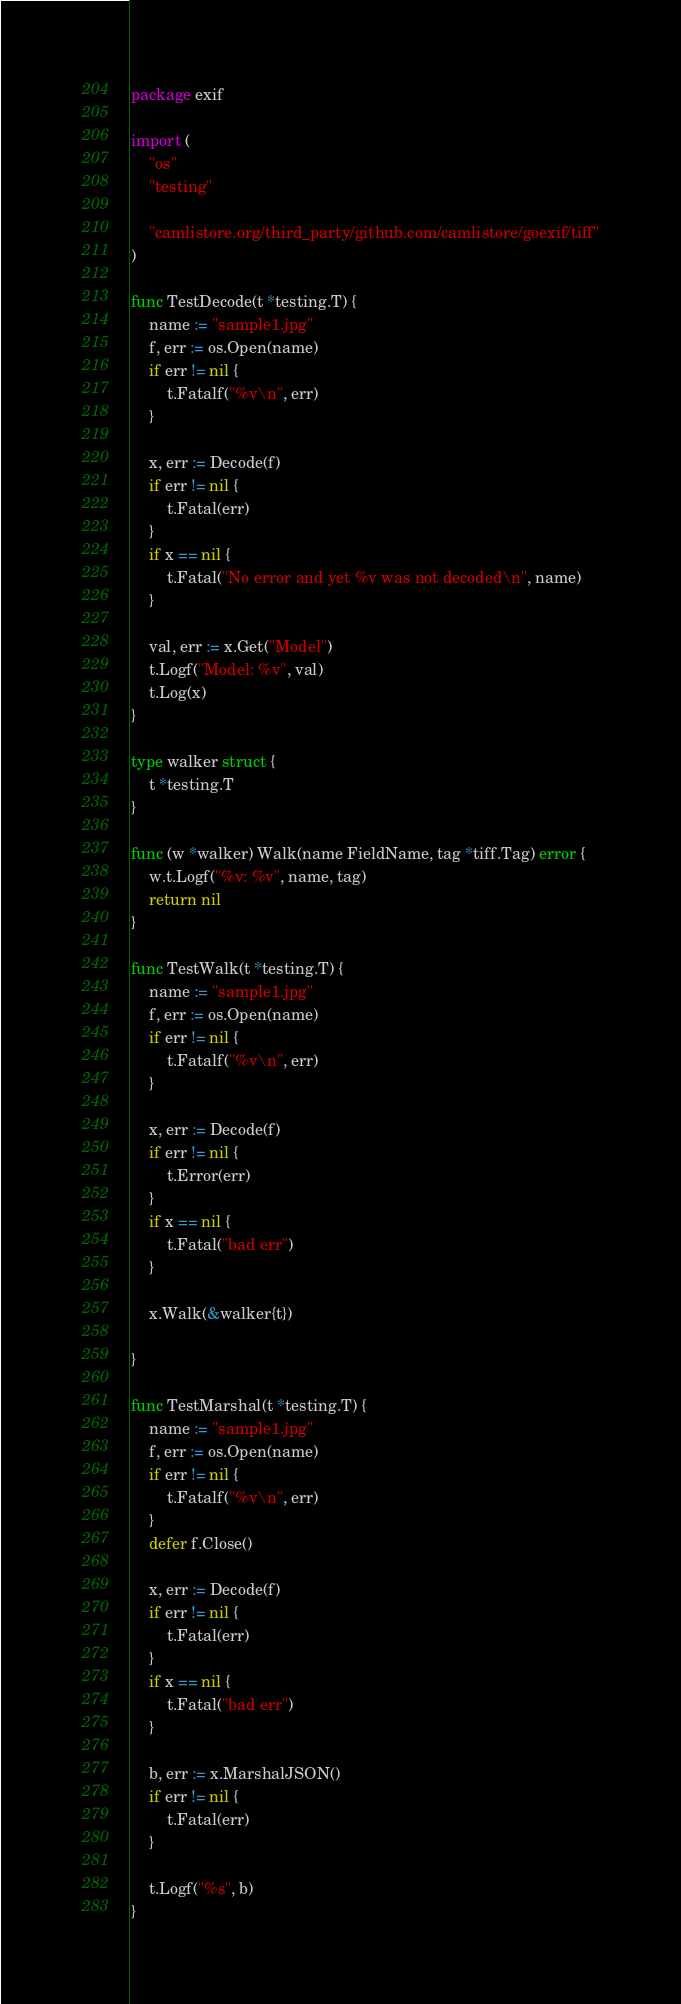Convert code to text. <code><loc_0><loc_0><loc_500><loc_500><_Go_>package exif

import (
	"os"
	"testing"

	"camlistore.org/third_party/github.com/camlistore/goexif/tiff"
)

func TestDecode(t *testing.T) {
	name := "sample1.jpg"
	f, err := os.Open(name)
	if err != nil {
		t.Fatalf("%v\n", err)
	}

	x, err := Decode(f)
	if err != nil {
		t.Fatal(err)
	}
	if x == nil {
		t.Fatal("No error and yet %v was not decoded\n", name)
	}

	val, err := x.Get("Model")
	t.Logf("Model: %v", val)
	t.Log(x)
}

type walker struct {
	t *testing.T
}

func (w *walker) Walk(name FieldName, tag *tiff.Tag) error {
	w.t.Logf("%v: %v", name, tag)
	return nil
}

func TestWalk(t *testing.T) {
	name := "sample1.jpg"
	f, err := os.Open(name)
	if err != nil {
		t.Fatalf("%v\n", err)
	}

	x, err := Decode(f)
	if err != nil {
		t.Error(err)
	}
	if x == nil {
		t.Fatal("bad err")
	}

	x.Walk(&walker{t})

}

func TestMarshal(t *testing.T) {
	name := "sample1.jpg"
	f, err := os.Open(name)
	if err != nil {
		t.Fatalf("%v\n", err)
	}
	defer f.Close()

	x, err := Decode(f)
	if err != nil {
		t.Fatal(err)
	}
	if x == nil {
		t.Fatal("bad err")
	}

	b, err := x.MarshalJSON()
	if err != nil {
		t.Fatal(err)
	}

	t.Logf("%s", b)
}
</code> 